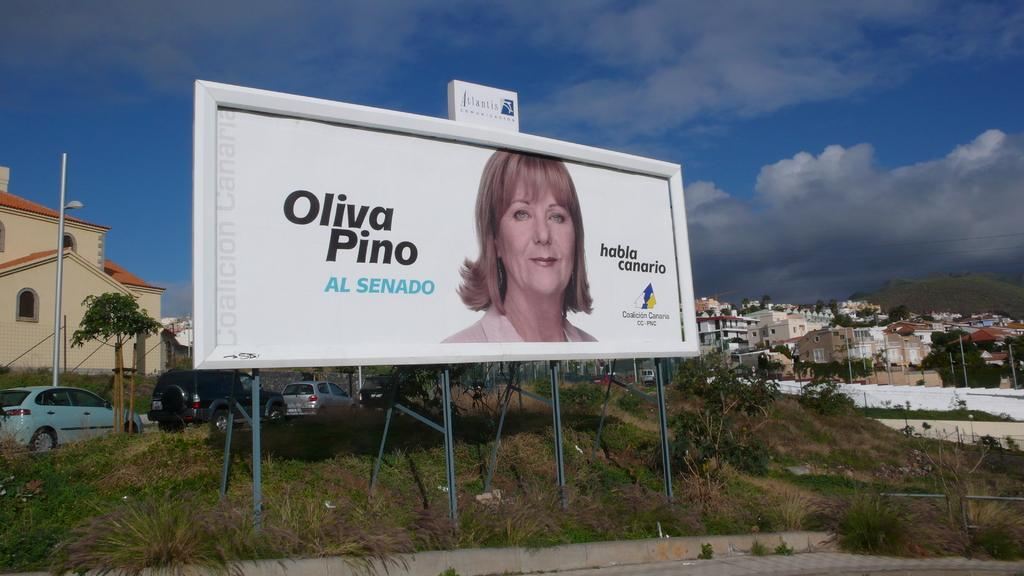<image>
Give a short and clear explanation of the subsequent image. a billboard ad for Oliva Pino Al Enado with a picture of her 